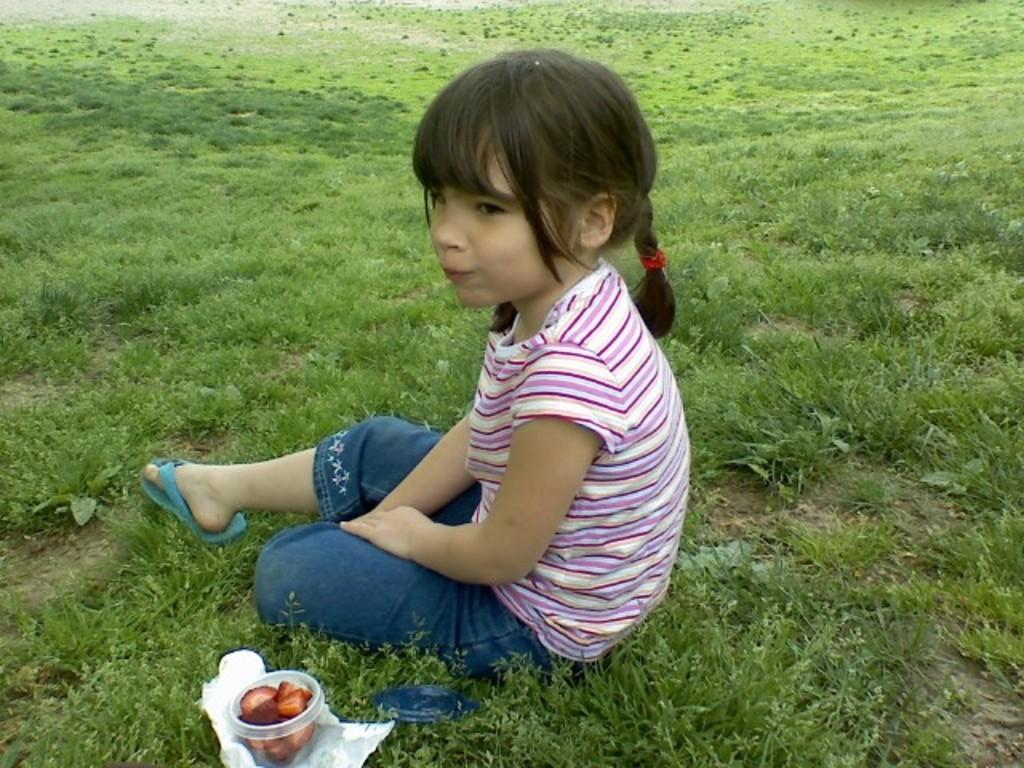What is the girl in the image doing? The girl is sitting on the grass in the image. What objects can be seen in the image besides the girl? There is a box, a paper, and food visible in the image. What type of badge is the girl wearing in the image? There is no badge visible on the girl in the image. What material is the hydrant made of in the image? There is no hydrant present in the image. 